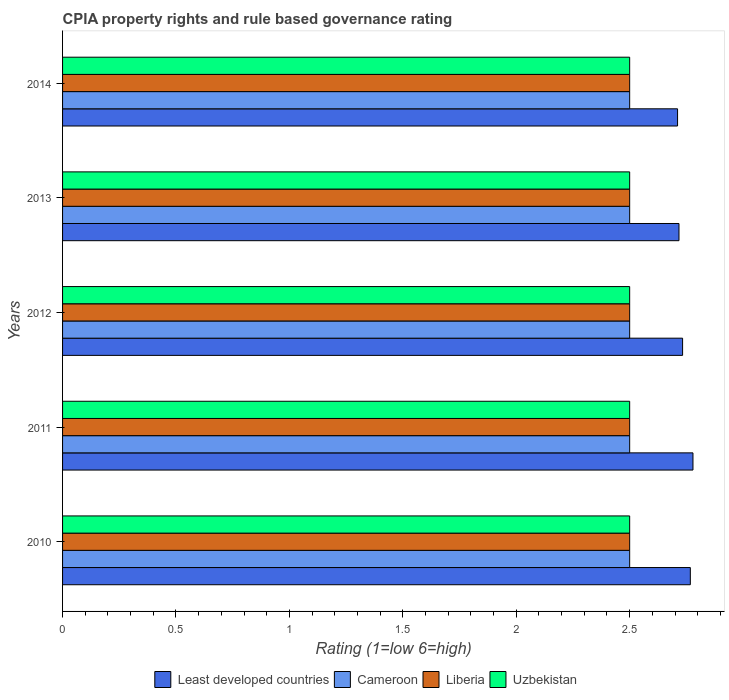Are the number of bars per tick equal to the number of legend labels?
Ensure brevity in your answer.  Yes. How many bars are there on the 3rd tick from the bottom?
Your response must be concise. 4. What is the difference between the CPIA rating in Cameroon in 2010 and that in 2013?
Make the answer very short. 0. What is the difference between the CPIA rating in Liberia in 2011 and the CPIA rating in Uzbekistan in 2012?
Provide a short and direct response. 0. What is the average CPIA rating in Liberia per year?
Your answer should be very brief. 2.5. In the year 2014, what is the difference between the CPIA rating in Uzbekistan and CPIA rating in Liberia?
Keep it short and to the point. 0. In how many years, is the CPIA rating in Liberia greater than 0.4 ?
Provide a short and direct response. 5. What is the difference between the highest and the second highest CPIA rating in Uzbekistan?
Provide a succinct answer. 0. Is the sum of the CPIA rating in Cameroon in 2013 and 2014 greater than the maximum CPIA rating in Least developed countries across all years?
Provide a succinct answer. Yes. What does the 4th bar from the top in 2014 represents?
Your response must be concise. Least developed countries. What does the 4th bar from the bottom in 2014 represents?
Keep it short and to the point. Uzbekistan. Are all the bars in the graph horizontal?
Offer a very short reply. Yes. How many years are there in the graph?
Give a very brief answer. 5. What is the difference between two consecutive major ticks on the X-axis?
Ensure brevity in your answer.  0.5. Are the values on the major ticks of X-axis written in scientific E-notation?
Ensure brevity in your answer.  No. Does the graph contain any zero values?
Your response must be concise. No. How many legend labels are there?
Provide a succinct answer. 4. What is the title of the graph?
Provide a short and direct response. CPIA property rights and rule based governance rating. What is the Rating (1=low 6=high) in Least developed countries in 2010?
Your response must be concise. 2.77. What is the Rating (1=low 6=high) of Least developed countries in 2011?
Keep it short and to the point. 2.78. What is the Rating (1=low 6=high) in Uzbekistan in 2011?
Provide a succinct answer. 2.5. What is the Rating (1=low 6=high) of Least developed countries in 2012?
Your answer should be compact. 2.73. What is the Rating (1=low 6=high) in Cameroon in 2012?
Provide a succinct answer. 2.5. What is the Rating (1=low 6=high) of Uzbekistan in 2012?
Your response must be concise. 2.5. What is the Rating (1=low 6=high) of Least developed countries in 2013?
Offer a terse response. 2.72. What is the Rating (1=low 6=high) in Least developed countries in 2014?
Provide a short and direct response. 2.71. What is the Rating (1=low 6=high) in Uzbekistan in 2014?
Provide a short and direct response. 2.5. Across all years, what is the maximum Rating (1=low 6=high) in Least developed countries?
Keep it short and to the point. 2.78. Across all years, what is the maximum Rating (1=low 6=high) in Liberia?
Your answer should be very brief. 2.5. Across all years, what is the minimum Rating (1=low 6=high) in Least developed countries?
Your answer should be very brief. 2.71. Across all years, what is the minimum Rating (1=low 6=high) of Uzbekistan?
Provide a short and direct response. 2.5. What is the total Rating (1=low 6=high) in Least developed countries in the graph?
Offer a very short reply. 13.71. What is the total Rating (1=low 6=high) of Liberia in the graph?
Offer a very short reply. 12.5. What is the difference between the Rating (1=low 6=high) in Least developed countries in 2010 and that in 2011?
Keep it short and to the point. -0.01. What is the difference between the Rating (1=low 6=high) in Least developed countries in 2010 and that in 2012?
Offer a terse response. 0.03. What is the difference between the Rating (1=low 6=high) in Liberia in 2010 and that in 2012?
Offer a terse response. 0. What is the difference between the Rating (1=low 6=high) of Uzbekistan in 2010 and that in 2012?
Ensure brevity in your answer.  0. What is the difference between the Rating (1=low 6=high) in Least developed countries in 2010 and that in 2013?
Give a very brief answer. 0.05. What is the difference between the Rating (1=low 6=high) in Liberia in 2010 and that in 2013?
Give a very brief answer. 0. What is the difference between the Rating (1=low 6=high) of Least developed countries in 2010 and that in 2014?
Your response must be concise. 0.06. What is the difference between the Rating (1=low 6=high) in Liberia in 2010 and that in 2014?
Your response must be concise. 0. What is the difference between the Rating (1=low 6=high) of Uzbekistan in 2010 and that in 2014?
Offer a very short reply. 0. What is the difference between the Rating (1=low 6=high) of Least developed countries in 2011 and that in 2012?
Ensure brevity in your answer.  0.05. What is the difference between the Rating (1=low 6=high) of Least developed countries in 2011 and that in 2013?
Keep it short and to the point. 0.06. What is the difference between the Rating (1=low 6=high) in Cameroon in 2011 and that in 2013?
Give a very brief answer. 0. What is the difference between the Rating (1=low 6=high) of Liberia in 2011 and that in 2013?
Ensure brevity in your answer.  0. What is the difference between the Rating (1=low 6=high) of Least developed countries in 2011 and that in 2014?
Offer a terse response. 0.07. What is the difference between the Rating (1=low 6=high) of Cameroon in 2011 and that in 2014?
Offer a very short reply. 0. What is the difference between the Rating (1=low 6=high) of Liberia in 2011 and that in 2014?
Your response must be concise. 0. What is the difference between the Rating (1=low 6=high) in Uzbekistan in 2011 and that in 2014?
Make the answer very short. 0. What is the difference between the Rating (1=low 6=high) in Least developed countries in 2012 and that in 2013?
Your response must be concise. 0.02. What is the difference between the Rating (1=low 6=high) of Least developed countries in 2012 and that in 2014?
Keep it short and to the point. 0.02. What is the difference between the Rating (1=low 6=high) in Cameroon in 2012 and that in 2014?
Provide a succinct answer. 0. What is the difference between the Rating (1=low 6=high) of Uzbekistan in 2012 and that in 2014?
Provide a short and direct response. 0. What is the difference between the Rating (1=low 6=high) in Least developed countries in 2013 and that in 2014?
Offer a very short reply. 0.01. What is the difference between the Rating (1=low 6=high) of Liberia in 2013 and that in 2014?
Your response must be concise. 0. What is the difference between the Rating (1=low 6=high) in Least developed countries in 2010 and the Rating (1=low 6=high) in Cameroon in 2011?
Your response must be concise. 0.27. What is the difference between the Rating (1=low 6=high) in Least developed countries in 2010 and the Rating (1=low 6=high) in Liberia in 2011?
Your answer should be compact. 0.27. What is the difference between the Rating (1=low 6=high) in Least developed countries in 2010 and the Rating (1=low 6=high) in Uzbekistan in 2011?
Provide a short and direct response. 0.27. What is the difference between the Rating (1=low 6=high) of Least developed countries in 2010 and the Rating (1=low 6=high) of Cameroon in 2012?
Provide a short and direct response. 0.27. What is the difference between the Rating (1=low 6=high) of Least developed countries in 2010 and the Rating (1=low 6=high) of Liberia in 2012?
Provide a short and direct response. 0.27. What is the difference between the Rating (1=low 6=high) in Least developed countries in 2010 and the Rating (1=low 6=high) in Uzbekistan in 2012?
Make the answer very short. 0.27. What is the difference between the Rating (1=low 6=high) in Cameroon in 2010 and the Rating (1=low 6=high) in Uzbekistan in 2012?
Your response must be concise. 0. What is the difference between the Rating (1=low 6=high) in Least developed countries in 2010 and the Rating (1=low 6=high) in Cameroon in 2013?
Offer a very short reply. 0.27. What is the difference between the Rating (1=low 6=high) of Least developed countries in 2010 and the Rating (1=low 6=high) of Liberia in 2013?
Your answer should be very brief. 0.27. What is the difference between the Rating (1=low 6=high) in Least developed countries in 2010 and the Rating (1=low 6=high) in Uzbekistan in 2013?
Make the answer very short. 0.27. What is the difference between the Rating (1=low 6=high) of Liberia in 2010 and the Rating (1=low 6=high) of Uzbekistan in 2013?
Provide a succinct answer. 0. What is the difference between the Rating (1=low 6=high) of Least developed countries in 2010 and the Rating (1=low 6=high) of Cameroon in 2014?
Your response must be concise. 0.27. What is the difference between the Rating (1=low 6=high) of Least developed countries in 2010 and the Rating (1=low 6=high) of Liberia in 2014?
Give a very brief answer. 0.27. What is the difference between the Rating (1=low 6=high) of Least developed countries in 2010 and the Rating (1=low 6=high) of Uzbekistan in 2014?
Your response must be concise. 0.27. What is the difference between the Rating (1=low 6=high) in Cameroon in 2010 and the Rating (1=low 6=high) in Liberia in 2014?
Ensure brevity in your answer.  0. What is the difference between the Rating (1=low 6=high) of Cameroon in 2010 and the Rating (1=low 6=high) of Uzbekistan in 2014?
Provide a succinct answer. 0. What is the difference between the Rating (1=low 6=high) in Liberia in 2010 and the Rating (1=low 6=high) in Uzbekistan in 2014?
Your answer should be compact. 0. What is the difference between the Rating (1=low 6=high) in Least developed countries in 2011 and the Rating (1=low 6=high) in Cameroon in 2012?
Ensure brevity in your answer.  0.28. What is the difference between the Rating (1=low 6=high) of Least developed countries in 2011 and the Rating (1=low 6=high) of Liberia in 2012?
Your answer should be very brief. 0.28. What is the difference between the Rating (1=low 6=high) of Least developed countries in 2011 and the Rating (1=low 6=high) of Uzbekistan in 2012?
Offer a terse response. 0.28. What is the difference between the Rating (1=low 6=high) of Cameroon in 2011 and the Rating (1=low 6=high) of Liberia in 2012?
Keep it short and to the point. 0. What is the difference between the Rating (1=low 6=high) in Cameroon in 2011 and the Rating (1=low 6=high) in Uzbekistan in 2012?
Your answer should be compact. 0. What is the difference between the Rating (1=low 6=high) of Least developed countries in 2011 and the Rating (1=low 6=high) of Cameroon in 2013?
Your answer should be very brief. 0.28. What is the difference between the Rating (1=low 6=high) in Least developed countries in 2011 and the Rating (1=low 6=high) in Liberia in 2013?
Ensure brevity in your answer.  0.28. What is the difference between the Rating (1=low 6=high) of Least developed countries in 2011 and the Rating (1=low 6=high) of Uzbekistan in 2013?
Provide a succinct answer. 0.28. What is the difference between the Rating (1=low 6=high) in Cameroon in 2011 and the Rating (1=low 6=high) in Liberia in 2013?
Make the answer very short. 0. What is the difference between the Rating (1=low 6=high) in Least developed countries in 2011 and the Rating (1=low 6=high) in Cameroon in 2014?
Ensure brevity in your answer.  0.28. What is the difference between the Rating (1=low 6=high) in Least developed countries in 2011 and the Rating (1=low 6=high) in Liberia in 2014?
Offer a very short reply. 0.28. What is the difference between the Rating (1=low 6=high) in Least developed countries in 2011 and the Rating (1=low 6=high) in Uzbekistan in 2014?
Offer a very short reply. 0.28. What is the difference between the Rating (1=low 6=high) in Cameroon in 2011 and the Rating (1=low 6=high) in Liberia in 2014?
Give a very brief answer. 0. What is the difference between the Rating (1=low 6=high) in Cameroon in 2011 and the Rating (1=low 6=high) in Uzbekistan in 2014?
Offer a very short reply. 0. What is the difference between the Rating (1=low 6=high) in Liberia in 2011 and the Rating (1=low 6=high) in Uzbekistan in 2014?
Your answer should be compact. 0. What is the difference between the Rating (1=low 6=high) of Least developed countries in 2012 and the Rating (1=low 6=high) of Cameroon in 2013?
Your answer should be very brief. 0.23. What is the difference between the Rating (1=low 6=high) of Least developed countries in 2012 and the Rating (1=low 6=high) of Liberia in 2013?
Keep it short and to the point. 0.23. What is the difference between the Rating (1=low 6=high) in Least developed countries in 2012 and the Rating (1=low 6=high) in Uzbekistan in 2013?
Make the answer very short. 0.23. What is the difference between the Rating (1=low 6=high) of Liberia in 2012 and the Rating (1=low 6=high) of Uzbekistan in 2013?
Offer a terse response. 0. What is the difference between the Rating (1=low 6=high) in Least developed countries in 2012 and the Rating (1=low 6=high) in Cameroon in 2014?
Your response must be concise. 0.23. What is the difference between the Rating (1=low 6=high) in Least developed countries in 2012 and the Rating (1=low 6=high) in Liberia in 2014?
Offer a very short reply. 0.23. What is the difference between the Rating (1=low 6=high) in Least developed countries in 2012 and the Rating (1=low 6=high) in Uzbekistan in 2014?
Provide a succinct answer. 0.23. What is the difference between the Rating (1=low 6=high) of Cameroon in 2012 and the Rating (1=low 6=high) of Uzbekistan in 2014?
Offer a very short reply. 0. What is the difference between the Rating (1=low 6=high) in Least developed countries in 2013 and the Rating (1=low 6=high) in Cameroon in 2014?
Offer a very short reply. 0.22. What is the difference between the Rating (1=low 6=high) of Least developed countries in 2013 and the Rating (1=low 6=high) of Liberia in 2014?
Your answer should be compact. 0.22. What is the difference between the Rating (1=low 6=high) in Least developed countries in 2013 and the Rating (1=low 6=high) in Uzbekistan in 2014?
Your response must be concise. 0.22. What is the average Rating (1=low 6=high) in Least developed countries per year?
Ensure brevity in your answer.  2.74. What is the average Rating (1=low 6=high) of Liberia per year?
Ensure brevity in your answer.  2.5. What is the average Rating (1=low 6=high) in Uzbekistan per year?
Keep it short and to the point. 2.5. In the year 2010, what is the difference between the Rating (1=low 6=high) in Least developed countries and Rating (1=low 6=high) in Cameroon?
Offer a terse response. 0.27. In the year 2010, what is the difference between the Rating (1=low 6=high) in Least developed countries and Rating (1=low 6=high) in Liberia?
Provide a succinct answer. 0.27. In the year 2010, what is the difference between the Rating (1=low 6=high) of Least developed countries and Rating (1=low 6=high) of Uzbekistan?
Offer a terse response. 0.27. In the year 2010, what is the difference between the Rating (1=low 6=high) in Cameroon and Rating (1=low 6=high) in Liberia?
Your response must be concise. 0. In the year 2010, what is the difference between the Rating (1=low 6=high) in Cameroon and Rating (1=low 6=high) in Uzbekistan?
Make the answer very short. 0. In the year 2010, what is the difference between the Rating (1=low 6=high) of Liberia and Rating (1=low 6=high) of Uzbekistan?
Your response must be concise. 0. In the year 2011, what is the difference between the Rating (1=low 6=high) of Least developed countries and Rating (1=low 6=high) of Cameroon?
Offer a terse response. 0.28. In the year 2011, what is the difference between the Rating (1=low 6=high) in Least developed countries and Rating (1=low 6=high) in Liberia?
Ensure brevity in your answer.  0.28. In the year 2011, what is the difference between the Rating (1=low 6=high) of Least developed countries and Rating (1=low 6=high) of Uzbekistan?
Offer a terse response. 0.28. In the year 2011, what is the difference between the Rating (1=low 6=high) in Cameroon and Rating (1=low 6=high) in Liberia?
Your answer should be very brief. 0. In the year 2011, what is the difference between the Rating (1=low 6=high) in Cameroon and Rating (1=low 6=high) in Uzbekistan?
Provide a short and direct response. 0. In the year 2011, what is the difference between the Rating (1=low 6=high) of Liberia and Rating (1=low 6=high) of Uzbekistan?
Ensure brevity in your answer.  0. In the year 2012, what is the difference between the Rating (1=low 6=high) in Least developed countries and Rating (1=low 6=high) in Cameroon?
Your answer should be very brief. 0.23. In the year 2012, what is the difference between the Rating (1=low 6=high) in Least developed countries and Rating (1=low 6=high) in Liberia?
Keep it short and to the point. 0.23. In the year 2012, what is the difference between the Rating (1=low 6=high) of Least developed countries and Rating (1=low 6=high) of Uzbekistan?
Provide a short and direct response. 0.23. In the year 2012, what is the difference between the Rating (1=low 6=high) in Cameroon and Rating (1=low 6=high) in Uzbekistan?
Your answer should be very brief. 0. In the year 2013, what is the difference between the Rating (1=low 6=high) of Least developed countries and Rating (1=low 6=high) of Cameroon?
Your response must be concise. 0.22. In the year 2013, what is the difference between the Rating (1=low 6=high) of Least developed countries and Rating (1=low 6=high) of Liberia?
Keep it short and to the point. 0.22. In the year 2013, what is the difference between the Rating (1=low 6=high) in Least developed countries and Rating (1=low 6=high) in Uzbekistan?
Your answer should be very brief. 0.22. In the year 2014, what is the difference between the Rating (1=low 6=high) in Least developed countries and Rating (1=low 6=high) in Cameroon?
Offer a very short reply. 0.21. In the year 2014, what is the difference between the Rating (1=low 6=high) in Least developed countries and Rating (1=low 6=high) in Liberia?
Provide a short and direct response. 0.21. In the year 2014, what is the difference between the Rating (1=low 6=high) in Least developed countries and Rating (1=low 6=high) in Uzbekistan?
Your response must be concise. 0.21. In the year 2014, what is the difference between the Rating (1=low 6=high) in Liberia and Rating (1=low 6=high) in Uzbekistan?
Offer a terse response. 0. What is the ratio of the Rating (1=low 6=high) of Cameroon in 2010 to that in 2011?
Keep it short and to the point. 1. What is the ratio of the Rating (1=low 6=high) of Least developed countries in 2010 to that in 2012?
Make the answer very short. 1.01. What is the ratio of the Rating (1=low 6=high) of Cameroon in 2010 to that in 2012?
Ensure brevity in your answer.  1. What is the ratio of the Rating (1=low 6=high) in Liberia in 2010 to that in 2012?
Give a very brief answer. 1. What is the ratio of the Rating (1=low 6=high) in Uzbekistan in 2010 to that in 2012?
Your answer should be very brief. 1. What is the ratio of the Rating (1=low 6=high) in Least developed countries in 2010 to that in 2013?
Your answer should be very brief. 1.02. What is the ratio of the Rating (1=low 6=high) in Uzbekistan in 2010 to that in 2013?
Offer a terse response. 1. What is the ratio of the Rating (1=low 6=high) of Least developed countries in 2010 to that in 2014?
Provide a succinct answer. 1.02. What is the ratio of the Rating (1=low 6=high) in Liberia in 2010 to that in 2014?
Your answer should be very brief. 1. What is the ratio of the Rating (1=low 6=high) of Uzbekistan in 2010 to that in 2014?
Keep it short and to the point. 1. What is the ratio of the Rating (1=low 6=high) of Least developed countries in 2011 to that in 2012?
Provide a succinct answer. 1.02. What is the ratio of the Rating (1=low 6=high) of Uzbekistan in 2011 to that in 2012?
Make the answer very short. 1. What is the ratio of the Rating (1=low 6=high) in Least developed countries in 2011 to that in 2013?
Provide a short and direct response. 1.02. What is the ratio of the Rating (1=low 6=high) in Liberia in 2011 to that in 2013?
Make the answer very short. 1. What is the ratio of the Rating (1=low 6=high) of Least developed countries in 2011 to that in 2014?
Your answer should be very brief. 1.03. What is the ratio of the Rating (1=low 6=high) in Cameroon in 2011 to that in 2014?
Provide a short and direct response. 1. What is the ratio of the Rating (1=low 6=high) of Liberia in 2011 to that in 2014?
Offer a terse response. 1. What is the ratio of the Rating (1=low 6=high) in Least developed countries in 2012 to that in 2013?
Offer a terse response. 1.01. What is the ratio of the Rating (1=low 6=high) of Cameroon in 2012 to that in 2013?
Your response must be concise. 1. What is the ratio of the Rating (1=low 6=high) in Liberia in 2012 to that in 2013?
Offer a terse response. 1. What is the ratio of the Rating (1=low 6=high) of Uzbekistan in 2012 to that in 2013?
Keep it short and to the point. 1. What is the ratio of the Rating (1=low 6=high) of Least developed countries in 2012 to that in 2014?
Provide a short and direct response. 1.01. What is the ratio of the Rating (1=low 6=high) of Cameroon in 2012 to that in 2014?
Offer a very short reply. 1. What is the ratio of the Rating (1=low 6=high) in Liberia in 2012 to that in 2014?
Your answer should be compact. 1. What is the ratio of the Rating (1=low 6=high) in Cameroon in 2013 to that in 2014?
Provide a succinct answer. 1. What is the ratio of the Rating (1=low 6=high) of Liberia in 2013 to that in 2014?
Provide a succinct answer. 1. What is the difference between the highest and the second highest Rating (1=low 6=high) in Least developed countries?
Give a very brief answer. 0.01. What is the difference between the highest and the second highest Rating (1=low 6=high) in Liberia?
Provide a short and direct response. 0. What is the difference between the highest and the second highest Rating (1=low 6=high) in Uzbekistan?
Provide a short and direct response. 0. What is the difference between the highest and the lowest Rating (1=low 6=high) in Least developed countries?
Give a very brief answer. 0.07. What is the difference between the highest and the lowest Rating (1=low 6=high) of Cameroon?
Give a very brief answer. 0. What is the difference between the highest and the lowest Rating (1=low 6=high) of Uzbekistan?
Your answer should be compact. 0. 